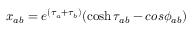<formula> <loc_0><loc_0><loc_500><loc_500>x _ { a b } = e ^ { ( \tau _ { a } + \tau _ { b } ) } ( \cosh \tau _ { a b } - \cos \phi _ { a b } )</formula> 